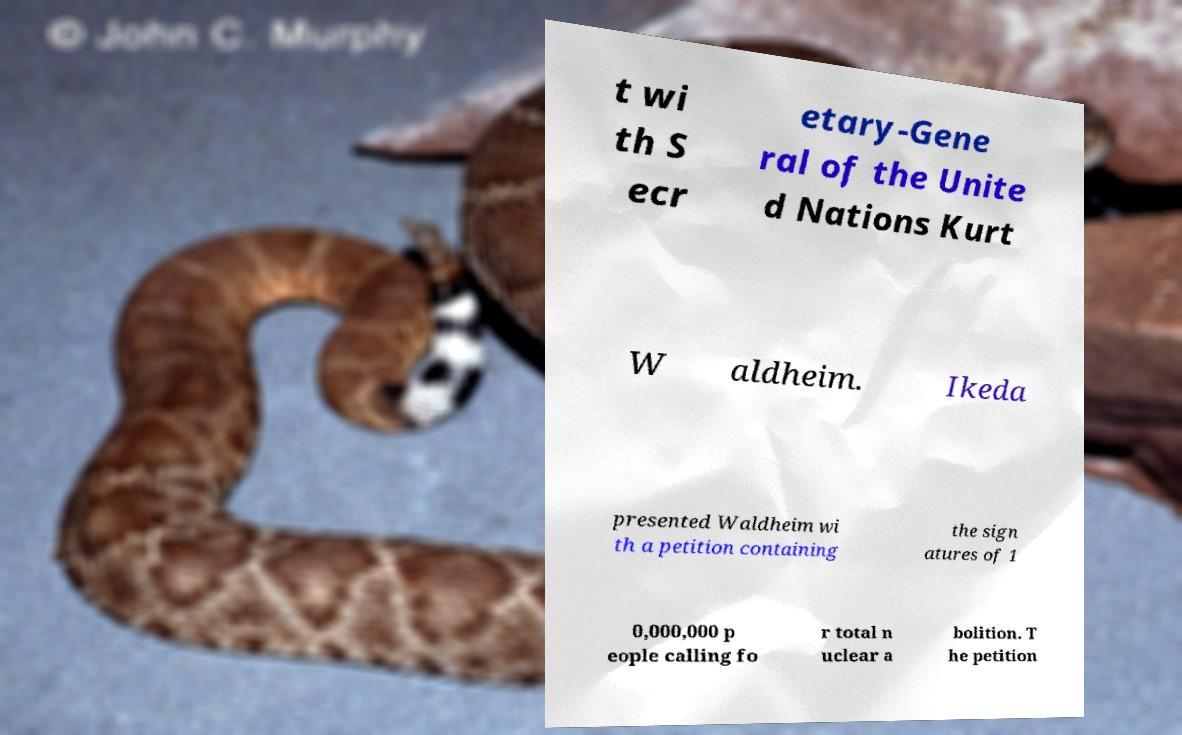There's text embedded in this image that I need extracted. Can you transcribe it verbatim? t wi th S ecr etary-Gene ral of the Unite d Nations Kurt W aldheim. Ikeda presented Waldheim wi th a petition containing the sign atures of 1 0,000,000 p eople calling fo r total n uclear a bolition. T he petition 